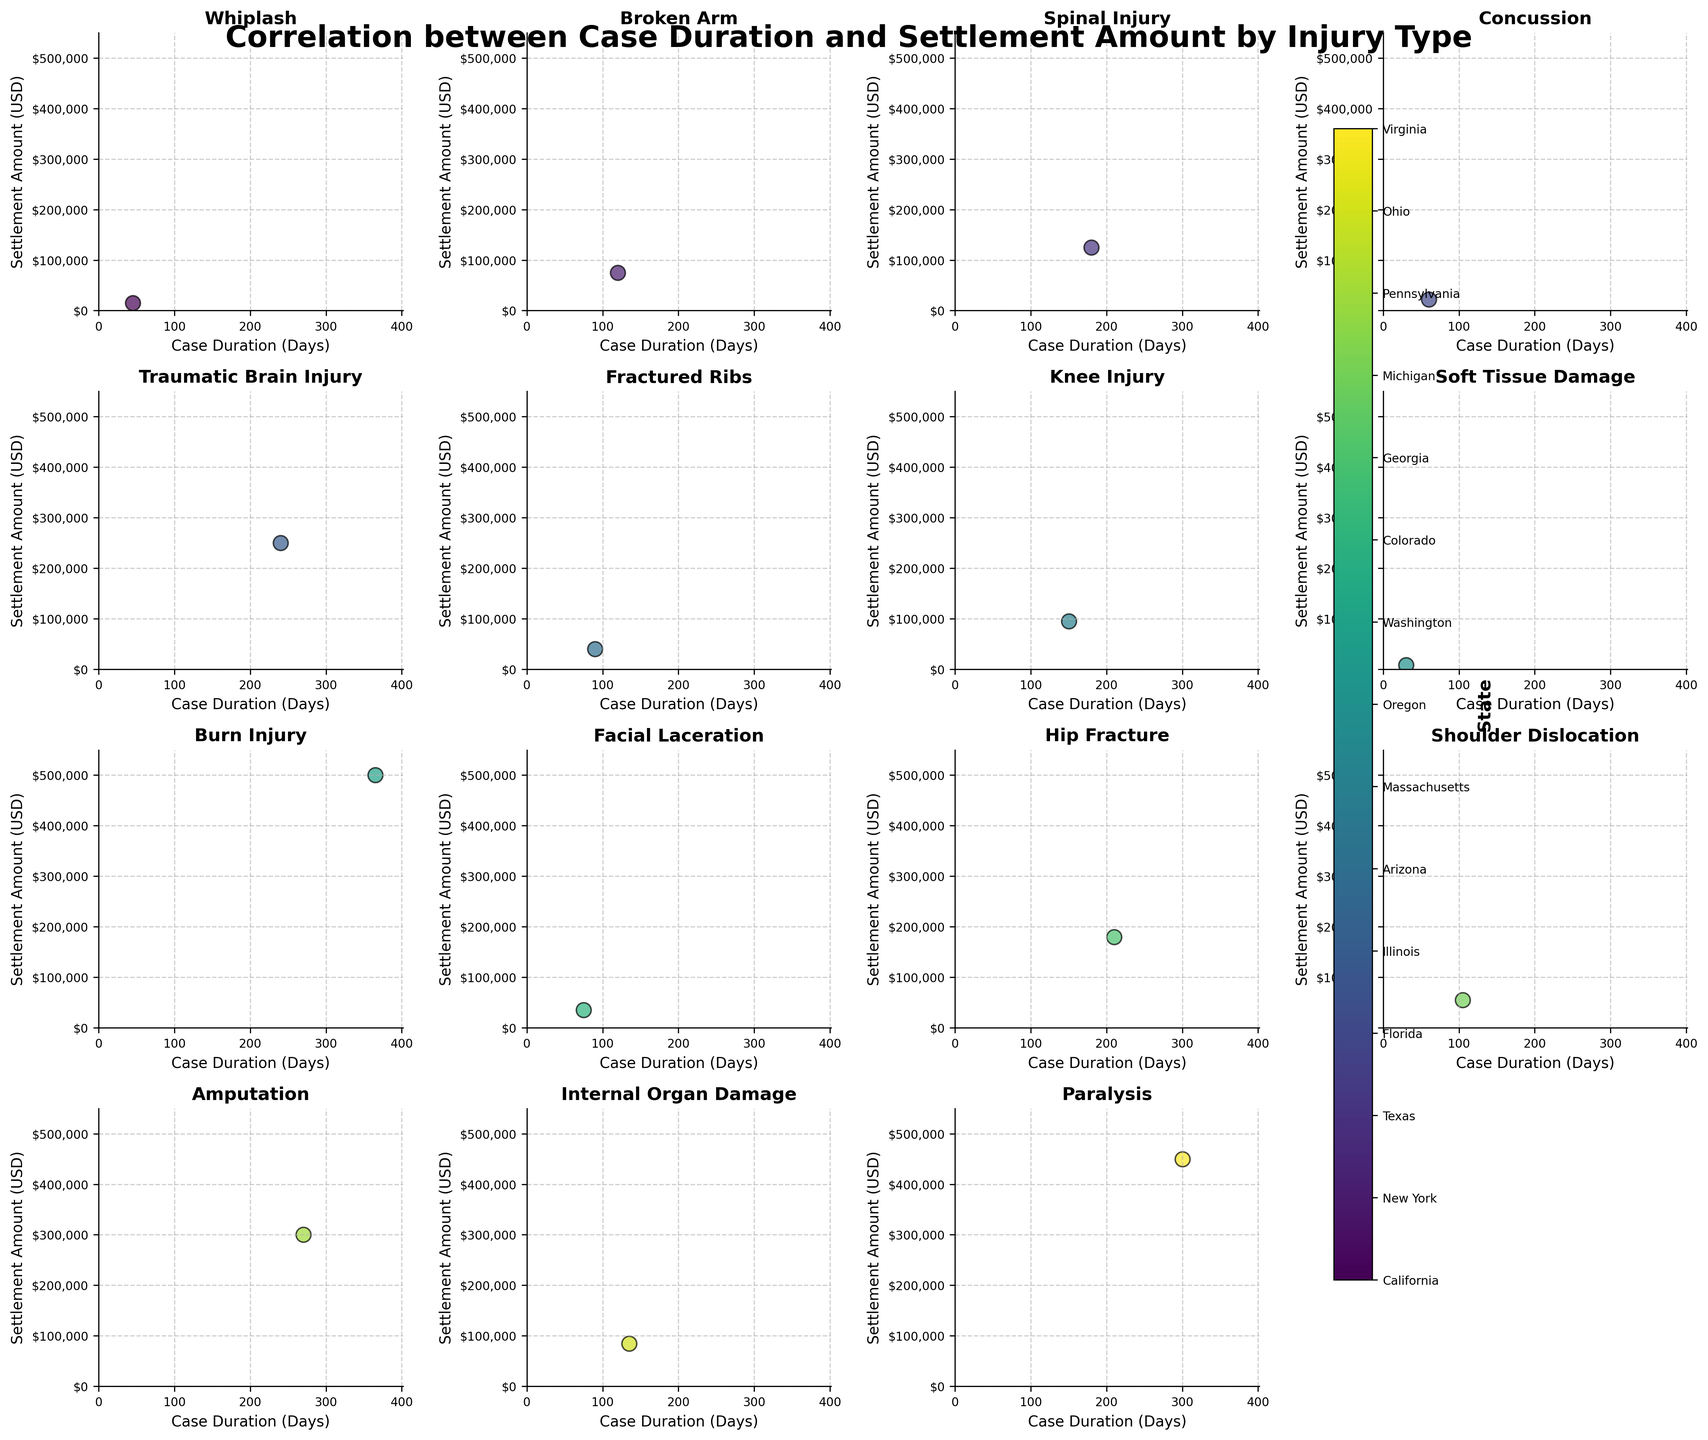what is the title of the plot? The title of the plot is written prominently at the top of the figure.
Answer: Correlation between Case Duration and Settlement Amount by Injury Type How many scatter plots are shown in total? The total number of scatter plots is equal to the number of unique injury types present in the figure.
Answer: 15 Which injury type has the highest settlement amount, and what is the amount? Locate the injury type where the highest point on the y-axis appears.
Answer: Burn Injury with $500,000 What is the injury type with the shortest case duration, and what is the duration? Locate the injury type where the leftmost point on the x-axis appears.
Answer: Soft Tissue Damage with 30 days Which states are represented by different colors in the scatter plots, and how are they labeled? The states are represented by different colors, typically indicated in a color bar or legend.
Answer: California, New York, Texas, Florida, Illinois, Arizona, Massachusetts, Oregon, Washington, Colorado, Georgia, Michigan, Pennsylvania, Ohio, Virginia What is the range of case duration observed in the plots? Find the minimum and maximum values along the x-axis for any of the plots.
Answer: 30 to 365 days Which injury type shows a case with a settlement amount below $50,000 and a duration above 100 days? Identify plots that contain points between the $50,000 mark on the y-axis and above the 100 days mark on the x-axis.
Answer: Shoulder Dislocation Are there any injury types with multiple states represented by different colors? If so, name one example. Identify any subplot with multiple color points, indicating different states.
Answer: Yes, for example, Facial Laceration What is the average settlement amount for cases with Concussion? Average the settlement amounts of the data points within the Concussion scatter plot.
Answer: $22,000 Which injury type has the most evenly distributed settlement amounts across different case durations? Look for the injury type where data points are spread out consistently horizontally.
Answer: Concussion 